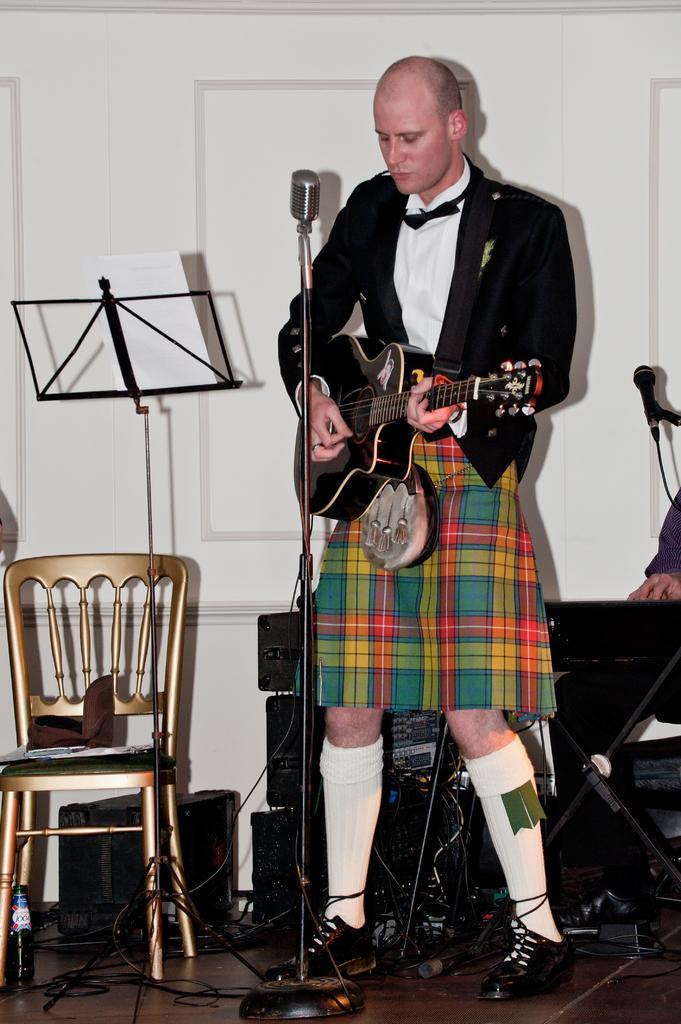Describe this image in one or two sentences. In the center we can see one person holding guitar,in front there is a microphone. On right we can see another person sitting and holding keyboard. On the left there is a chair and bag. In the bottom we can see bottle and wire. In the background there is a door and speaker. 